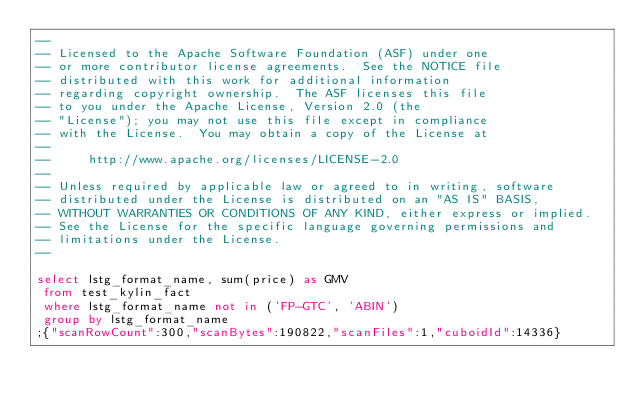Convert code to text. <code><loc_0><loc_0><loc_500><loc_500><_SQL_>--
-- Licensed to the Apache Software Foundation (ASF) under one
-- or more contributor license agreements.  See the NOTICE file
-- distributed with this work for additional information
-- regarding copyright ownership.  The ASF licenses this file
-- to you under the Apache License, Version 2.0 (the
-- "License"); you may not use this file except in compliance
-- with the License.  You may obtain a copy of the License at
--
--     http://www.apache.org/licenses/LICENSE-2.0
--
-- Unless required by applicable law or agreed to in writing, software
-- distributed under the License is distributed on an "AS IS" BASIS,
-- WITHOUT WARRANTIES OR CONDITIONS OF ANY KIND, either express or implied.
-- See the License for the specific language governing permissions and
-- limitations under the License.
--

select lstg_format_name, sum(price) as GMV 
 from test_kylin_fact 
 where lstg_format_name not in ('FP-GTC', 'ABIN') 
 group by lstg_format_name
;{"scanRowCount":300,"scanBytes":190822,"scanFiles":1,"cuboidId":14336}</code> 